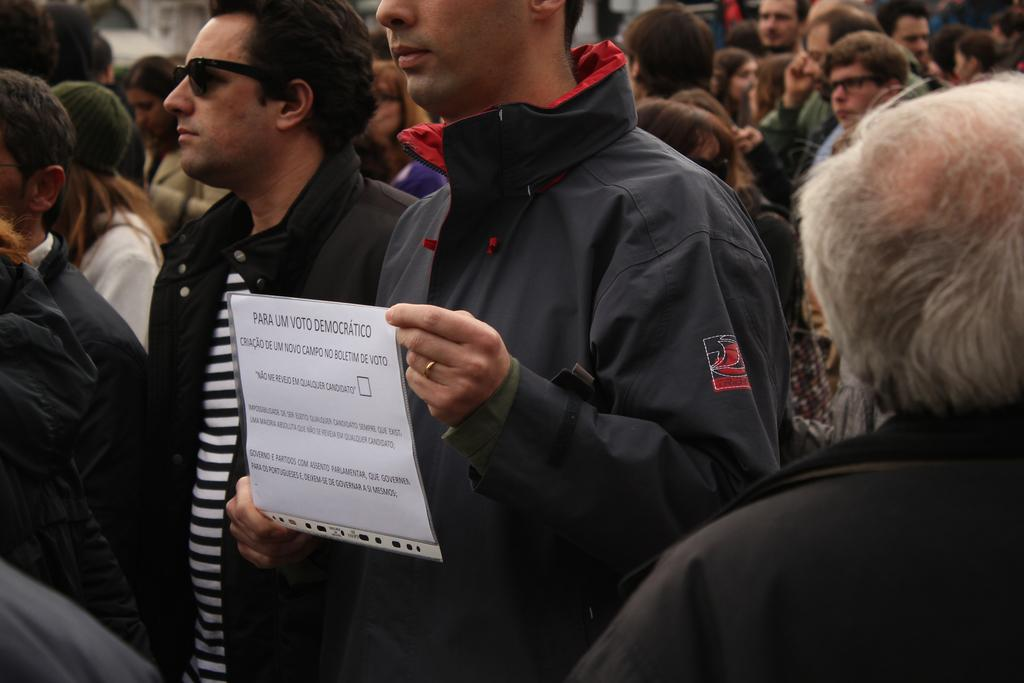What is the main subject of the image? The main subject of the image is a group of people. Can you describe any specific actions or objects being held by the people in the image? Yes, there is a person holding a paper in his hands. What type of pig can be seen in the image? There is no pig present in the image. What is the color of the door in the image? There is no door present in the image. 